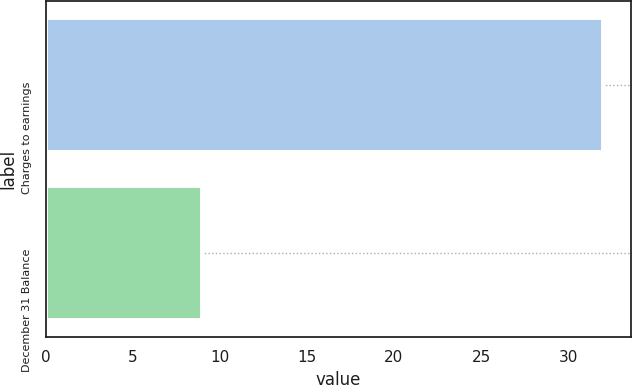<chart> <loc_0><loc_0><loc_500><loc_500><bar_chart><fcel>Charges to earnings<fcel>December 31 Balance<nl><fcel>32<fcel>9<nl></chart> 